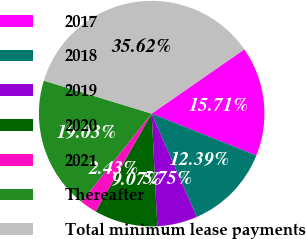Convert chart to OTSL. <chart><loc_0><loc_0><loc_500><loc_500><pie_chart><fcel>2017<fcel>2018<fcel>2019<fcel>2020<fcel>2021<fcel>Thereafter<fcel>Total minimum lease payments<nl><fcel>15.71%<fcel>12.39%<fcel>5.75%<fcel>9.07%<fcel>2.43%<fcel>19.03%<fcel>35.62%<nl></chart> 